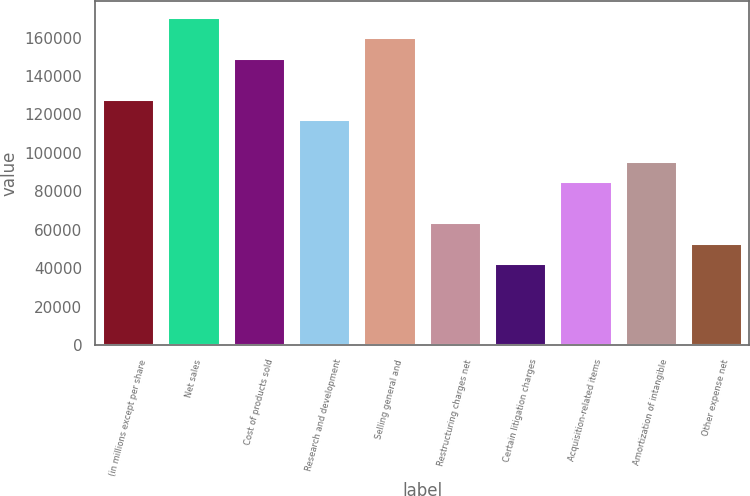Convert chart to OTSL. <chart><loc_0><loc_0><loc_500><loc_500><bar_chart><fcel>(in millions except per share<fcel>Net sales<fcel>Cost of products sold<fcel>Research and development<fcel>Selling general and<fcel>Restructuring charges net<fcel>Certain litigation charges<fcel>Acquisition-related items<fcel>Amortization of intangible<fcel>Other expense net<nl><fcel>128022<fcel>170695<fcel>149359<fcel>117353<fcel>160027<fcel>64011.5<fcel>42674.7<fcel>85348.3<fcel>96016.6<fcel>53343.1<nl></chart> 